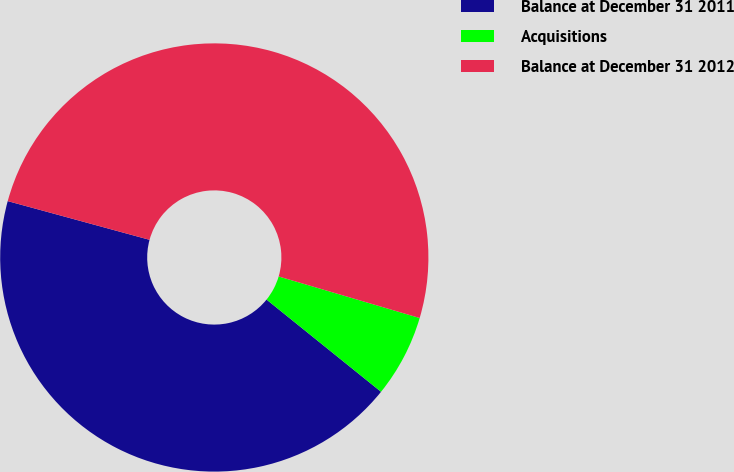Convert chart. <chart><loc_0><loc_0><loc_500><loc_500><pie_chart><fcel>Balance at December 31 2011<fcel>Acquisitions<fcel>Balance at December 31 2012<nl><fcel>43.45%<fcel>6.23%<fcel>50.32%<nl></chart> 